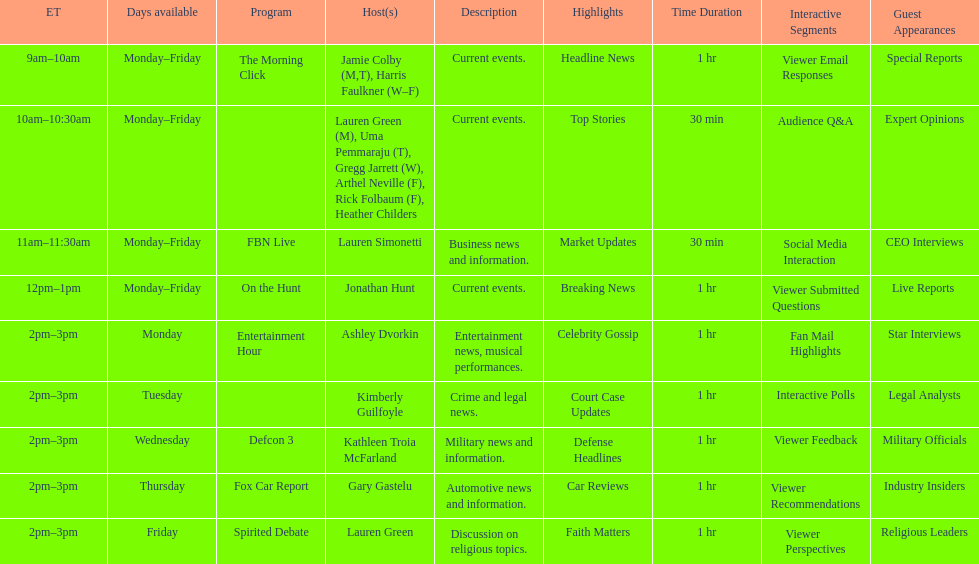Tell me who has her show on fridays at 2. Lauren Green. 